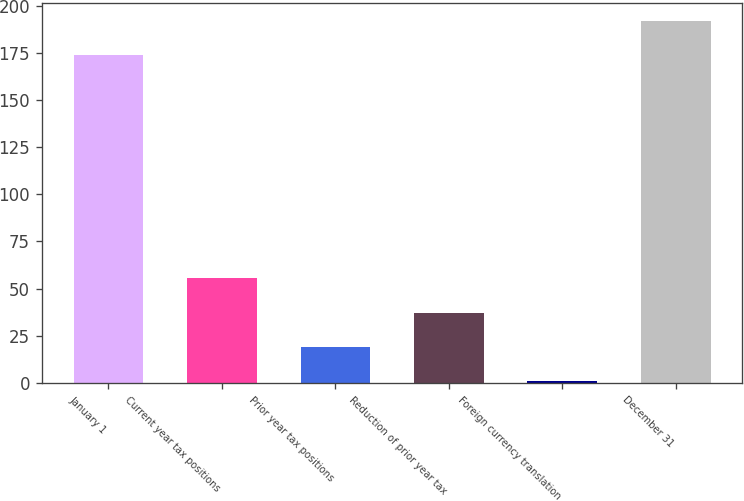Convert chart. <chart><loc_0><loc_0><loc_500><loc_500><bar_chart><fcel>January 1<fcel>Current year tax positions<fcel>Prior year tax positions<fcel>Reduction of prior year tax<fcel>Foreign currency translation<fcel>December 31<nl><fcel>173.7<fcel>55.4<fcel>19<fcel>37.2<fcel>0.8<fcel>191.9<nl></chart> 